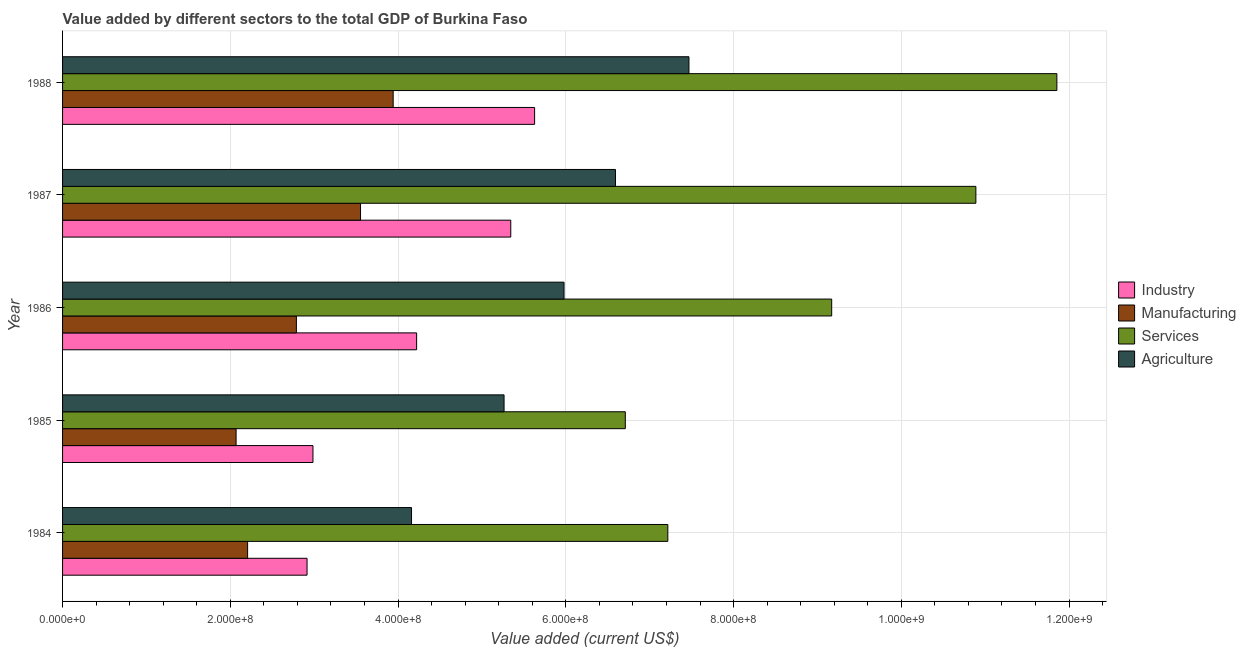How many different coloured bars are there?
Provide a succinct answer. 4. How many groups of bars are there?
Make the answer very short. 5. Are the number of bars per tick equal to the number of legend labels?
Provide a succinct answer. Yes. How many bars are there on the 3rd tick from the top?
Your response must be concise. 4. What is the label of the 2nd group of bars from the top?
Make the answer very short. 1987. What is the value added by industrial sector in 1986?
Provide a short and direct response. 4.22e+08. Across all years, what is the maximum value added by services sector?
Provide a short and direct response. 1.19e+09. Across all years, what is the minimum value added by industrial sector?
Ensure brevity in your answer.  2.91e+08. What is the total value added by services sector in the graph?
Provide a succinct answer. 4.58e+09. What is the difference between the value added by industrial sector in 1985 and that in 1987?
Your response must be concise. -2.36e+08. What is the difference between the value added by industrial sector in 1987 and the value added by manufacturing sector in 1985?
Offer a terse response. 3.27e+08. What is the average value added by industrial sector per year?
Offer a very short reply. 4.22e+08. In the year 1987, what is the difference between the value added by manufacturing sector and value added by industrial sector?
Keep it short and to the point. -1.79e+08. In how many years, is the value added by manufacturing sector greater than 840000000 US$?
Your answer should be very brief. 0. What is the ratio of the value added by services sector in 1985 to that in 1988?
Make the answer very short. 0.57. Is the difference between the value added by services sector in 1984 and 1985 greater than the difference between the value added by manufacturing sector in 1984 and 1985?
Give a very brief answer. Yes. What is the difference between the highest and the second highest value added by agricultural sector?
Your answer should be compact. 8.76e+07. What is the difference between the highest and the lowest value added by agricultural sector?
Give a very brief answer. 3.31e+08. Is it the case that in every year, the sum of the value added by services sector and value added by industrial sector is greater than the sum of value added by agricultural sector and value added by manufacturing sector?
Give a very brief answer. Yes. What does the 3rd bar from the top in 1986 represents?
Offer a very short reply. Manufacturing. What does the 2nd bar from the bottom in 1988 represents?
Your response must be concise. Manufacturing. Is it the case that in every year, the sum of the value added by industrial sector and value added by manufacturing sector is greater than the value added by services sector?
Your answer should be very brief. No. How many bars are there?
Your answer should be very brief. 20. Are all the bars in the graph horizontal?
Your answer should be very brief. Yes. What is the difference between two consecutive major ticks on the X-axis?
Make the answer very short. 2.00e+08. Does the graph contain any zero values?
Your answer should be compact. No. Does the graph contain grids?
Give a very brief answer. Yes. Where does the legend appear in the graph?
Provide a succinct answer. Center right. How are the legend labels stacked?
Provide a succinct answer. Vertical. What is the title of the graph?
Provide a short and direct response. Value added by different sectors to the total GDP of Burkina Faso. Does "Plant species" appear as one of the legend labels in the graph?
Make the answer very short. No. What is the label or title of the X-axis?
Provide a short and direct response. Value added (current US$). What is the label or title of the Y-axis?
Provide a succinct answer. Year. What is the Value added (current US$) in Industry in 1984?
Ensure brevity in your answer.  2.91e+08. What is the Value added (current US$) of Manufacturing in 1984?
Make the answer very short. 2.21e+08. What is the Value added (current US$) in Services in 1984?
Give a very brief answer. 7.22e+08. What is the Value added (current US$) in Agriculture in 1984?
Make the answer very short. 4.16e+08. What is the Value added (current US$) of Industry in 1985?
Keep it short and to the point. 2.99e+08. What is the Value added (current US$) of Manufacturing in 1985?
Your answer should be compact. 2.07e+08. What is the Value added (current US$) of Services in 1985?
Offer a terse response. 6.71e+08. What is the Value added (current US$) in Agriculture in 1985?
Your answer should be compact. 5.26e+08. What is the Value added (current US$) of Industry in 1986?
Ensure brevity in your answer.  4.22e+08. What is the Value added (current US$) of Manufacturing in 1986?
Your answer should be compact. 2.79e+08. What is the Value added (current US$) of Services in 1986?
Keep it short and to the point. 9.17e+08. What is the Value added (current US$) in Agriculture in 1986?
Your response must be concise. 5.98e+08. What is the Value added (current US$) of Industry in 1987?
Ensure brevity in your answer.  5.34e+08. What is the Value added (current US$) of Manufacturing in 1987?
Your answer should be very brief. 3.55e+08. What is the Value added (current US$) of Services in 1987?
Make the answer very short. 1.09e+09. What is the Value added (current US$) in Agriculture in 1987?
Keep it short and to the point. 6.59e+08. What is the Value added (current US$) in Industry in 1988?
Provide a short and direct response. 5.63e+08. What is the Value added (current US$) in Manufacturing in 1988?
Ensure brevity in your answer.  3.94e+08. What is the Value added (current US$) in Services in 1988?
Your answer should be very brief. 1.19e+09. What is the Value added (current US$) of Agriculture in 1988?
Your answer should be compact. 7.47e+08. Across all years, what is the maximum Value added (current US$) in Industry?
Your answer should be compact. 5.63e+08. Across all years, what is the maximum Value added (current US$) of Manufacturing?
Provide a succinct answer. 3.94e+08. Across all years, what is the maximum Value added (current US$) of Services?
Offer a terse response. 1.19e+09. Across all years, what is the maximum Value added (current US$) of Agriculture?
Your response must be concise. 7.47e+08. Across all years, what is the minimum Value added (current US$) of Industry?
Offer a terse response. 2.91e+08. Across all years, what is the minimum Value added (current US$) of Manufacturing?
Your response must be concise. 2.07e+08. Across all years, what is the minimum Value added (current US$) of Services?
Provide a short and direct response. 6.71e+08. Across all years, what is the minimum Value added (current US$) of Agriculture?
Give a very brief answer. 4.16e+08. What is the total Value added (current US$) of Industry in the graph?
Provide a short and direct response. 2.11e+09. What is the total Value added (current US$) of Manufacturing in the graph?
Your response must be concise. 1.46e+09. What is the total Value added (current US$) of Services in the graph?
Ensure brevity in your answer.  4.58e+09. What is the total Value added (current US$) of Agriculture in the graph?
Your answer should be very brief. 2.95e+09. What is the difference between the Value added (current US$) in Industry in 1984 and that in 1985?
Offer a terse response. -7.06e+06. What is the difference between the Value added (current US$) of Manufacturing in 1984 and that in 1985?
Your answer should be very brief. 1.37e+07. What is the difference between the Value added (current US$) of Services in 1984 and that in 1985?
Your response must be concise. 5.07e+07. What is the difference between the Value added (current US$) in Agriculture in 1984 and that in 1985?
Ensure brevity in your answer.  -1.10e+08. What is the difference between the Value added (current US$) in Industry in 1984 and that in 1986?
Ensure brevity in your answer.  -1.31e+08. What is the difference between the Value added (current US$) in Manufacturing in 1984 and that in 1986?
Your response must be concise. -5.82e+07. What is the difference between the Value added (current US$) of Services in 1984 and that in 1986?
Give a very brief answer. -1.95e+08. What is the difference between the Value added (current US$) of Agriculture in 1984 and that in 1986?
Offer a very short reply. -1.82e+08. What is the difference between the Value added (current US$) of Industry in 1984 and that in 1987?
Make the answer very short. -2.43e+08. What is the difference between the Value added (current US$) in Manufacturing in 1984 and that in 1987?
Provide a succinct answer. -1.35e+08. What is the difference between the Value added (current US$) in Services in 1984 and that in 1987?
Keep it short and to the point. -3.67e+08. What is the difference between the Value added (current US$) in Agriculture in 1984 and that in 1987?
Provide a short and direct response. -2.43e+08. What is the difference between the Value added (current US$) of Industry in 1984 and that in 1988?
Make the answer very short. -2.71e+08. What is the difference between the Value added (current US$) of Manufacturing in 1984 and that in 1988?
Provide a succinct answer. -1.74e+08. What is the difference between the Value added (current US$) in Services in 1984 and that in 1988?
Ensure brevity in your answer.  -4.64e+08. What is the difference between the Value added (current US$) in Agriculture in 1984 and that in 1988?
Ensure brevity in your answer.  -3.31e+08. What is the difference between the Value added (current US$) in Industry in 1985 and that in 1986?
Offer a terse response. -1.24e+08. What is the difference between the Value added (current US$) of Manufacturing in 1985 and that in 1986?
Make the answer very short. -7.19e+07. What is the difference between the Value added (current US$) of Services in 1985 and that in 1986?
Keep it short and to the point. -2.46e+08. What is the difference between the Value added (current US$) in Agriculture in 1985 and that in 1986?
Keep it short and to the point. -7.15e+07. What is the difference between the Value added (current US$) of Industry in 1985 and that in 1987?
Ensure brevity in your answer.  -2.36e+08. What is the difference between the Value added (current US$) of Manufacturing in 1985 and that in 1987?
Your response must be concise. -1.48e+08. What is the difference between the Value added (current US$) of Services in 1985 and that in 1987?
Provide a short and direct response. -4.18e+08. What is the difference between the Value added (current US$) of Agriculture in 1985 and that in 1987?
Your answer should be very brief. -1.33e+08. What is the difference between the Value added (current US$) in Industry in 1985 and that in 1988?
Provide a succinct answer. -2.64e+08. What is the difference between the Value added (current US$) of Manufacturing in 1985 and that in 1988?
Ensure brevity in your answer.  -1.87e+08. What is the difference between the Value added (current US$) of Services in 1985 and that in 1988?
Give a very brief answer. -5.15e+08. What is the difference between the Value added (current US$) of Agriculture in 1985 and that in 1988?
Keep it short and to the point. -2.20e+08. What is the difference between the Value added (current US$) of Industry in 1986 and that in 1987?
Your answer should be very brief. -1.12e+08. What is the difference between the Value added (current US$) of Manufacturing in 1986 and that in 1987?
Ensure brevity in your answer.  -7.65e+07. What is the difference between the Value added (current US$) in Services in 1986 and that in 1987?
Your answer should be very brief. -1.72e+08. What is the difference between the Value added (current US$) of Agriculture in 1986 and that in 1987?
Your answer should be compact. -6.13e+07. What is the difference between the Value added (current US$) in Industry in 1986 and that in 1988?
Ensure brevity in your answer.  -1.41e+08. What is the difference between the Value added (current US$) of Manufacturing in 1986 and that in 1988?
Give a very brief answer. -1.15e+08. What is the difference between the Value added (current US$) in Services in 1986 and that in 1988?
Your response must be concise. -2.68e+08. What is the difference between the Value added (current US$) of Agriculture in 1986 and that in 1988?
Offer a very short reply. -1.49e+08. What is the difference between the Value added (current US$) of Industry in 1987 and that in 1988?
Keep it short and to the point. -2.84e+07. What is the difference between the Value added (current US$) in Manufacturing in 1987 and that in 1988?
Give a very brief answer. -3.89e+07. What is the difference between the Value added (current US$) in Services in 1987 and that in 1988?
Make the answer very short. -9.66e+07. What is the difference between the Value added (current US$) in Agriculture in 1987 and that in 1988?
Your response must be concise. -8.76e+07. What is the difference between the Value added (current US$) of Industry in 1984 and the Value added (current US$) of Manufacturing in 1985?
Your answer should be very brief. 8.46e+07. What is the difference between the Value added (current US$) of Industry in 1984 and the Value added (current US$) of Services in 1985?
Your answer should be compact. -3.79e+08. What is the difference between the Value added (current US$) of Industry in 1984 and the Value added (current US$) of Agriculture in 1985?
Offer a very short reply. -2.35e+08. What is the difference between the Value added (current US$) in Manufacturing in 1984 and the Value added (current US$) in Services in 1985?
Your answer should be very brief. -4.50e+08. What is the difference between the Value added (current US$) of Manufacturing in 1984 and the Value added (current US$) of Agriculture in 1985?
Your answer should be very brief. -3.06e+08. What is the difference between the Value added (current US$) of Services in 1984 and the Value added (current US$) of Agriculture in 1985?
Your response must be concise. 1.95e+08. What is the difference between the Value added (current US$) in Industry in 1984 and the Value added (current US$) in Manufacturing in 1986?
Ensure brevity in your answer.  1.27e+07. What is the difference between the Value added (current US$) in Industry in 1984 and the Value added (current US$) in Services in 1986?
Your answer should be very brief. -6.25e+08. What is the difference between the Value added (current US$) of Industry in 1984 and the Value added (current US$) of Agriculture in 1986?
Your answer should be compact. -3.06e+08. What is the difference between the Value added (current US$) in Manufacturing in 1984 and the Value added (current US$) in Services in 1986?
Provide a short and direct response. -6.96e+08. What is the difference between the Value added (current US$) in Manufacturing in 1984 and the Value added (current US$) in Agriculture in 1986?
Offer a very short reply. -3.77e+08. What is the difference between the Value added (current US$) of Services in 1984 and the Value added (current US$) of Agriculture in 1986?
Your response must be concise. 1.24e+08. What is the difference between the Value added (current US$) in Industry in 1984 and the Value added (current US$) in Manufacturing in 1987?
Your answer should be compact. -6.38e+07. What is the difference between the Value added (current US$) in Industry in 1984 and the Value added (current US$) in Services in 1987?
Offer a very short reply. -7.97e+08. What is the difference between the Value added (current US$) of Industry in 1984 and the Value added (current US$) of Agriculture in 1987?
Offer a terse response. -3.68e+08. What is the difference between the Value added (current US$) of Manufacturing in 1984 and the Value added (current US$) of Services in 1987?
Your response must be concise. -8.68e+08. What is the difference between the Value added (current US$) of Manufacturing in 1984 and the Value added (current US$) of Agriculture in 1987?
Your answer should be very brief. -4.39e+08. What is the difference between the Value added (current US$) of Services in 1984 and the Value added (current US$) of Agriculture in 1987?
Your answer should be compact. 6.24e+07. What is the difference between the Value added (current US$) of Industry in 1984 and the Value added (current US$) of Manufacturing in 1988?
Your response must be concise. -1.03e+08. What is the difference between the Value added (current US$) of Industry in 1984 and the Value added (current US$) of Services in 1988?
Offer a terse response. -8.94e+08. What is the difference between the Value added (current US$) of Industry in 1984 and the Value added (current US$) of Agriculture in 1988?
Make the answer very short. -4.55e+08. What is the difference between the Value added (current US$) in Manufacturing in 1984 and the Value added (current US$) in Services in 1988?
Give a very brief answer. -9.65e+08. What is the difference between the Value added (current US$) in Manufacturing in 1984 and the Value added (current US$) in Agriculture in 1988?
Offer a terse response. -5.26e+08. What is the difference between the Value added (current US$) of Services in 1984 and the Value added (current US$) of Agriculture in 1988?
Offer a terse response. -2.52e+07. What is the difference between the Value added (current US$) in Industry in 1985 and the Value added (current US$) in Manufacturing in 1986?
Provide a succinct answer. 1.98e+07. What is the difference between the Value added (current US$) of Industry in 1985 and the Value added (current US$) of Services in 1986?
Your response must be concise. -6.18e+08. What is the difference between the Value added (current US$) in Industry in 1985 and the Value added (current US$) in Agriculture in 1986?
Keep it short and to the point. -2.99e+08. What is the difference between the Value added (current US$) in Manufacturing in 1985 and the Value added (current US$) in Services in 1986?
Provide a short and direct response. -7.10e+08. What is the difference between the Value added (current US$) in Manufacturing in 1985 and the Value added (current US$) in Agriculture in 1986?
Your answer should be compact. -3.91e+08. What is the difference between the Value added (current US$) of Services in 1985 and the Value added (current US$) of Agriculture in 1986?
Provide a succinct answer. 7.31e+07. What is the difference between the Value added (current US$) of Industry in 1985 and the Value added (current US$) of Manufacturing in 1987?
Provide a succinct answer. -5.67e+07. What is the difference between the Value added (current US$) in Industry in 1985 and the Value added (current US$) in Services in 1987?
Your answer should be compact. -7.90e+08. What is the difference between the Value added (current US$) in Industry in 1985 and the Value added (current US$) in Agriculture in 1987?
Provide a succinct answer. -3.61e+08. What is the difference between the Value added (current US$) in Manufacturing in 1985 and the Value added (current US$) in Services in 1987?
Your answer should be compact. -8.82e+08. What is the difference between the Value added (current US$) in Manufacturing in 1985 and the Value added (current US$) in Agriculture in 1987?
Ensure brevity in your answer.  -4.52e+08. What is the difference between the Value added (current US$) in Services in 1985 and the Value added (current US$) in Agriculture in 1987?
Give a very brief answer. 1.17e+07. What is the difference between the Value added (current US$) in Industry in 1985 and the Value added (current US$) in Manufacturing in 1988?
Give a very brief answer. -9.56e+07. What is the difference between the Value added (current US$) in Industry in 1985 and the Value added (current US$) in Services in 1988?
Your response must be concise. -8.87e+08. What is the difference between the Value added (current US$) in Industry in 1985 and the Value added (current US$) in Agriculture in 1988?
Offer a terse response. -4.48e+08. What is the difference between the Value added (current US$) in Manufacturing in 1985 and the Value added (current US$) in Services in 1988?
Offer a very short reply. -9.79e+08. What is the difference between the Value added (current US$) in Manufacturing in 1985 and the Value added (current US$) in Agriculture in 1988?
Offer a very short reply. -5.40e+08. What is the difference between the Value added (current US$) in Services in 1985 and the Value added (current US$) in Agriculture in 1988?
Provide a succinct answer. -7.59e+07. What is the difference between the Value added (current US$) of Industry in 1986 and the Value added (current US$) of Manufacturing in 1987?
Provide a short and direct response. 6.69e+07. What is the difference between the Value added (current US$) of Industry in 1986 and the Value added (current US$) of Services in 1987?
Your answer should be compact. -6.67e+08. What is the difference between the Value added (current US$) in Industry in 1986 and the Value added (current US$) in Agriculture in 1987?
Your answer should be very brief. -2.37e+08. What is the difference between the Value added (current US$) in Manufacturing in 1986 and the Value added (current US$) in Services in 1987?
Your answer should be very brief. -8.10e+08. What is the difference between the Value added (current US$) of Manufacturing in 1986 and the Value added (current US$) of Agriculture in 1987?
Provide a short and direct response. -3.80e+08. What is the difference between the Value added (current US$) of Services in 1986 and the Value added (current US$) of Agriculture in 1987?
Keep it short and to the point. 2.58e+08. What is the difference between the Value added (current US$) in Industry in 1986 and the Value added (current US$) in Manufacturing in 1988?
Your response must be concise. 2.80e+07. What is the difference between the Value added (current US$) in Industry in 1986 and the Value added (current US$) in Services in 1988?
Ensure brevity in your answer.  -7.63e+08. What is the difference between the Value added (current US$) of Industry in 1986 and the Value added (current US$) of Agriculture in 1988?
Make the answer very short. -3.25e+08. What is the difference between the Value added (current US$) of Manufacturing in 1986 and the Value added (current US$) of Services in 1988?
Provide a succinct answer. -9.07e+08. What is the difference between the Value added (current US$) of Manufacturing in 1986 and the Value added (current US$) of Agriculture in 1988?
Provide a short and direct response. -4.68e+08. What is the difference between the Value added (current US$) in Services in 1986 and the Value added (current US$) in Agriculture in 1988?
Ensure brevity in your answer.  1.70e+08. What is the difference between the Value added (current US$) of Industry in 1987 and the Value added (current US$) of Manufacturing in 1988?
Your response must be concise. 1.40e+08. What is the difference between the Value added (current US$) in Industry in 1987 and the Value added (current US$) in Services in 1988?
Make the answer very short. -6.51e+08. What is the difference between the Value added (current US$) in Industry in 1987 and the Value added (current US$) in Agriculture in 1988?
Make the answer very short. -2.12e+08. What is the difference between the Value added (current US$) of Manufacturing in 1987 and the Value added (current US$) of Services in 1988?
Provide a succinct answer. -8.30e+08. What is the difference between the Value added (current US$) of Manufacturing in 1987 and the Value added (current US$) of Agriculture in 1988?
Provide a succinct answer. -3.92e+08. What is the difference between the Value added (current US$) in Services in 1987 and the Value added (current US$) in Agriculture in 1988?
Offer a very short reply. 3.42e+08. What is the average Value added (current US$) in Industry per year?
Offer a terse response. 4.22e+08. What is the average Value added (current US$) of Manufacturing per year?
Give a very brief answer. 2.91e+08. What is the average Value added (current US$) of Services per year?
Provide a succinct answer. 9.17e+08. What is the average Value added (current US$) of Agriculture per year?
Provide a succinct answer. 5.89e+08. In the year 1984, what is the difference between the Value added (current US$) of Industry and Value added (current US$) of Manufacturing?
Make the answer very short. 7.09e+07. In the year 1984, what is the difference between the Value added (current US$) of Industry and Value added (current US$) of Services?
Your answer should be compact. -4.30e+08. In the year 1984, what is the difference between the Value added (current US$) in Industry and Value added (current US$) in Agriculture?
Give a very brief answer. -1.25e+08. In the year 1984, what is the difference between the Value added (current US$) of Manufacturing and Value added (current US$) of Services?
Make the answer very short. -5.01e+08. In the year 1984, what is the difference between the Value added (current US$) in Manufacturing and Value added (current US$) in Agriculture?
Make the answer very short. -1.95e+08. In the year 1984, what is the difference between the Value added (current US$) of Services and Value added (current US$) of Agriculture?
Ensure brevity in your answer.  3.06e+08. In the year 1985, what is the difference between the Value added (current US$) in Industry and Value added (current US$) in Manufacturing?
Offer a very short reply. 9.17e+07. In the year 1985, what is the difference between the Value added (current US$) in Industry and Value added (current US$) in Services?
Give a very brief answer. -3.72e+08. In the year 1985, what is the difference between the Value added (current US$) of Industry and Value added (current US$) of Agriculture?
Provide a short and direct response. -2.28e+08. In the year 1985, what is the difference between the Value added (current US$) of Manufacturing and Value added (current US$) of Services?
Your answer should be very brief. -4.64e+08. In the year 1985, what is the difference between the Value added (current US$) in Manufacturing and Value added (current US$) in Agriculture?
Your response must be concise. -3.19e+08. In the year 1985, what is the difference between the Value added (current US$) in Services and Value added (current US$) in Agriculture?
Give a very brief answer. 1.45e+08. In the year 1986, what is the difference between the Value added (current US$) in Industry and Value added (current US$) in Manufacturing?
Offer a very short reply. 1.43e+08. In the year 1986, what is the difference between the Value added (current US$) in Industry and Value added (current US$) in Services?
Ensure brevity in your answer.  -4.95e+08. In the year 1986, what is the difference between the Value added (current US$) in Industry and Value added (current US$) in Agriculture?
Your response must be concise. -1.76e+08. In the year 1986, what is the difference between the Value added (current US$) in Manufacturing and Value added (current US$) in Services?
Your answer should be very brief. -6.38e+08. In the year 1986, what is the difference between the Value added (current US$) in Manufacturing and Value added (current US$) in Agriculture?
Your answer should be compact. -3.19e+08. In the year 1986, what is the difference between the Value added (current US$) in Services and Value added (current US$) in Agriculture?
Provide a short and direct response. 3.19e+08. In the year 1987, what is the difference between the Value added (current US$) of Industry and Value added (current US$) of Manufacturing?
Your answer should be compact. 1.79e+08. In the year 1987, what is the difference between the Value added (current US$) in Industry and Value added (current US$) in Services?
Make the answer very short. -5.55e+08. In the year 1987, what is the difference between the Value added (current US$) of Industry and Value added (current US$) of Agriculture?
Make the answer very short. -1.25e+08. In the year 1987, what is the difference between the Value added (current US$) in Manufacturing and Value added (current US$) in Services?
Give a very brief answer. -7.34e+08. In the year 1987, what is the difference between the Value added (current US$) of Manufacturing and Value added (current US$) of Agriculture?
Offer a terse response. -3.04e+08. In the year 1987, what is the difference between the Value added (current US$) in Services and Value added (current US$) in Agriculture?
Make the answer very short. 4.30e+08. In the year 1988, what is the difference between the Value added (current US$) of Industry and Value added (current US$) of Manufacturing?
Your response must be concise. 1.69e+08. In the year 1988, what is the difference between the Value added (current US$) of Industry and Value added (current US$) of Services?
Give a very brief answer. -6.23e+08. In the year 1988, what is the difference between the Value added (current US$) in Industry and Value added (current US$) in Agriculture?
Provide a short and direct response. -1.84e+08. In the year 1988, what is the difference between the Value added (current US$) of Manufacturing and Value added (current US$) of Services?
Your response must be concise. -7.91e+08. In the year 1988, what is the difference between the Value added (current US$) of Manufacturing and Value added (current US$) of Agriculture?
Offer a very short reply. -3.53e+08. In the year 1988, what is the difference between the Value added (current US$) in Services and Value added (current US$) in Agriculture?
Your answer should be very brief. 4.39e+08. What is the ratio of the Value added (current US$) of Industry in 1984 to that in 1985?
Offer a very short reply. 0.98. What is the ratio of the Value added (current US$) of Manufacturing in 1984 to that in 1985?
Keep it short and to the point. 1.07. What is the ratio of the Value added (current US$) of Services in 1984 to that in 1985?
Offer a terse response. 1.08. What is the ratio of the Value added (current US$) of Agriculture in 1984 to that in 1985?
Your response must be concise. 0.79. What is the ratio of the Value added (current US$) in Industry in 1984 to that in 1986?
Offer a very short reply. 0.69. What is the ratio of the Value added (current US$) of Manufacturing in 1984 to that in 1986?
Make the answer very short. 0.79. What is the ratio of the Value added (current US$) of Services in 1984 to that in 1986?
Make the answer very short. 0.79. What is the ratio of the Value added (current US$) in Agriculture in 1984 to that in 1986?
Offer a very short reply. 0.7. What is the ratio of the Value added (current US$) in Industry in 1984 to that in 1987?
Provide a succinct answer. 0.55. What is the ratio of the Value added (current US$) in Manufacturing in 1984 to that in 1987?
Your answer should be very brief. 0.62. What is the ratio of the Value added (current US$) in Services in 1984 to that in 1987?
Ensure brevity in your answer.  0.66. What is the ratio of the Value added (current US$) in Agriculture in 1984 to that in 1987?
Ensure brevity in your answer.  0.63. What is the ratio of the Value added (current US$) of Industry in 1984 to that in 1988?
Your answer should be very brief. 0.52. What is the ratio of the Value added (current US$) of Manufacturing in 1984 to that in 1988?
Make the answer very short. 0.56. What is the ratio of the Value added (current US$) in Services in 1984 to that in 1988?
Offer a very short reply. 0.61. What is the ratio of the Value added (current US$) in Agriculture in 1984 to that in 1988?
Your response must be concise. 0.56. What is the ratio of the Value added (current US$) in Industry in 1985 to that in 1986?
Offer a very short reply. 0.71. What is the ratio of the Value added (current US$) in Manufacturing in 1985 to that in 1986?
Your response must be concise. 0.74. What is the ratio of the Value added (current US$) of Services in 1985 to that in 1986?
Make the answer very short. 0.73. What is the ratio of the Value added (current US$) of Agriculture in 1985 to that in 1986?
Make the answer very short. 0.88. What is the ratio of the Value added (current US$) in Industry in 1985 to that in 1987?
Provide a short and direct response. 0.56. What is the ratio of the Value added (current US$) of Manufacturing in 1985 to that in 1987?
Your answer should be compact. 0.58. What is the ratio of the Value added (current US$) in Services in 1985 to that in 1987?
Keep it short and to the point. 0.62. What is the ratio of the Value added (current US$) of Agriculture in 1985 to that in 1987?
Provide a short and direct response. 0.8. What is the ratio of the Value added (current US$) in Industry in 1985 to that in 1988?
Give a very brief answer. 0.53. What is the ratio of the Value added (current US$) in Manufacturing in 1985 to that in 1988?
Provide a short and direct response. 0.52. What is the ratio of the Value added (current US$) of Services in 1985 to that in 1988?
Make the answer very short. 0.57. What is the ratio of the Value added (current US$) in Agriculture in 1985 to that in 1988?
Your response must be concise. 0.7. What is the ratio of the Value added (current US$) in Industry in 1986 to that in 1987?
Give a very brief answer. 0.79. What is the ratio of the Value added (current US$) in Manufacturing in 1986 to that in 1987?
Ensure brevity in your answer.  0.78. What is the ratio of the Value added (current US$) of Services in 1986 to that in 1987?
Your answer should be compact. 0.84. What is the ratio of the Value added (current US$) in Agriculture in 1986 to that in 1987?
Provide a short and direct response. 0.91. What is the ratio of the Value added (current US$) in Industry in 1986 to that in 1988?
Offer a terse response. 0.75. What is the ratio of the Value added (current US$) in Manufacturing in 1986 to that in 1988?
Offer a terse response. 0.71. What is the ratio of the Value added (current US$) of Services in 1986 to that in 1988?
Provide a short and direct response. 0.77. What is the ratio of the Value added (current US$) in Agriculture in 1986 to that in 1988?
Keep it short and to the point. 0.8. What is the ratio of the Value added (current US$) in Industry in 1987 to that in 1988?
Keep it short and to the point. 0.95. What is the ratio of the Value added (current US$) of Manufacturing in 1987 to that in 1988?
Your answer should be compact. 0.9. What is the ratio of the Value added (current US$) in Services in 1987 to that in 1988?
Offer a very short reply. 0.92. What is the ratio of the Value added (current US$) of Agriculture in 1987 to that in 1988?
Your answer should be very brief. 0.88. What is the difference between the highest and the second highest Value added (current US$) in Industry?
Ensure brevity in your answer.  2.84e+07. What is the difference between the highest and the second highest Value added (current US$) in Manufacturing?
Offer a very short reply. 3.89e+07. What is the difference between the highest and the second highest Value added (current US$) in Services?
Ensure brevity in your answer.  9.66e+07. What is the difference between the highest and the second highest Value added (current US$) in Agriculture?
Your response must be concise. 8.76e+07. What is the difference between the highest and the lowest Value added (current US$) of Industry?
Your response must be concise. 2.71e+08. What is the difference between the highest and the lowest Value added (current US$) in Manufacturing?
Give a very brief answer. 1.87e+08. What is the difference between the highest and the lowest Value added (current US$) in Services?
Your response must be concise. 5.15e+08. What is the difference between the highest and the lowest Value added (current US$) in Agriculture?
Provide a short and direct response. 3.31e+08. 